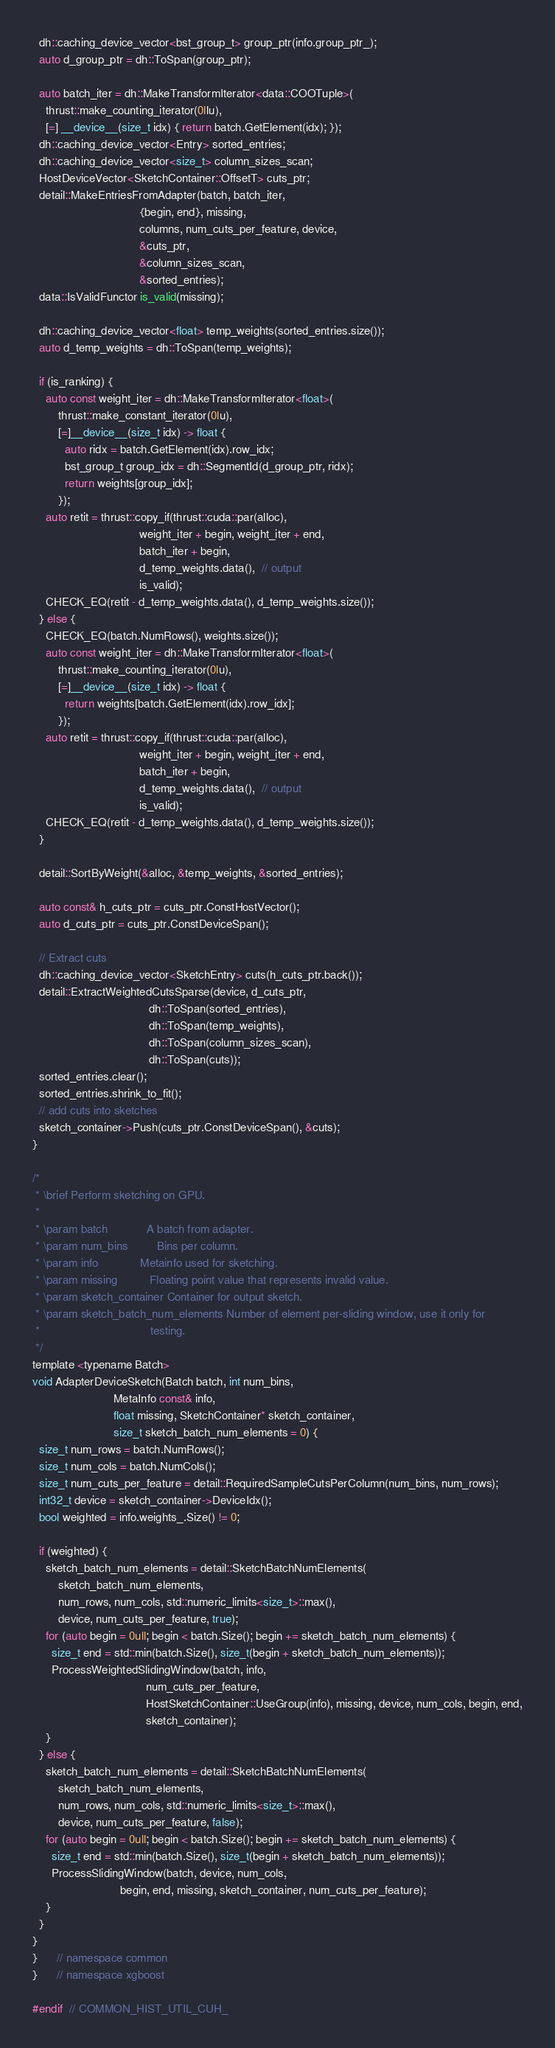Convert code to text. <code><loc_0><loc_0><loc_500><loc_500><_Cuda_>  dh::caching_device_vector<bst_group_t> group_ptr(info.group_ptr_);
  auto d_group_ptr = dh::ToSpan(group_ptr);

  auto batch_iter = dh::MakeTransformIterator<data::COOTuple>(
    thrust::make_counting_iterator(0llu),
    [=] __device__(size_t idx) { return batch.GetElement(idx); });
  dh::caching_device_vector<Entry> sorted_entries;
  dh::caching_device_vector<size_t> column_sizes_scan;
  HostDeviceVector<SketchContainer::OffsetT> cuts_ptr;
  detail::MakeEntriesFromAdapter(batch, batch_iter,
                                 {begin, end}, missing,
                                 columns, num_cuts_per_feature, device,
                                 &cuts_ptr,
                                 &column_sizes_scan,
                                 &sorted_entries);
  data::IsValidFunctor is_valid(missing);

  dh::caching_device_vector<float> temp_weights(sorted_entries.size());
  auto d_temp_weights = dh::ToSpan(temp_weights);

  if (is_ranking) {
    auto const weight_iter = dh::MakeTransformIterator<float>(
        thrust::make_constant_iterator(0lu),
        [=]__device__(size_t idx) -> float {
          auto ridx = batch.GetElement(idx).row_idx;
          bst_group_t group_idx = dh::SegmentId(d_group_ptr, ridx);
          return weights[group_idx];
        });
    auto retit = thrust::copy_if(thrust::cuda::par(alloc),
                                 weight_iter + begin, weight_iter + end,
                                 batch_iter + begin,
                                 d_temp_weights.data(),  // output
                                 is_valid);
    CHECK_EQ(retit - d_temp_weights.data(), d_temp_weights.size());
  } else {
    CHECK_EQ(batch.NumRows(), weights.size());
    auto const weight_iter = dh::MakeTransformIterator<float>(
        thrust::make_counting_iterator(0lu),
        [=]__device__(size_t idx) -> float {
          return weights[batch.GetElement(idx).row_idx];
        });
    auto retit = thrust::copy_if(thrust::cuda::par(alloc),
                                 weight_iter + begin, weight_iter + end,
                                 batch_iter + begin,
                                 d_temp_weights.data(),  // output
                                 is_valid);
    CHECK_EQ(retit - d_temp_weights.data(), d_temp_weights.size());
  }

  detail::SortByWeight(&alloc, &temp_weights, &sorted_entries);

  auto const& h_cuts_ptr = cuts_ptr.ConstHostVector();
  auto d_cuts_ptr = cuts_ptr.ConstDeviceSpan();

  // Extract cuts
  dh::caching_device_vector<SketchEntry> cuts(h_cuts_ptr.back());
  detail::ExtractWeightedCutsSparse(device, d_cuts_ptr,
                                    dh::ToSpan(sorted_entries),
                                    dh::ToSpan(temp_weights),
                                    dh::ToSpan(column_sizes_scan),
                                    dh::ToSpan(cuts));
  sorted_entries.clear();
  sorted_entries.shrink_to_fit();
  // add cuts into sketches
  sketch_container->Push(cuts_ptr.ConstDeviceSpan(), &cuts);
}

/*
 * \brief Perform sketching on GPU.
 *
 * \param batch            A batch from adapter.
 * \param num_bins         Bins per column.
 * \param info             Metainfo used for sketching.
 * \param missing          Floating point value that represents invalid value.
 * \param sketch_container Container for output sketch.
 * \param sketch_batch_num_elements Number of element per-sliding window, use it only for
 *                                  testing.
 */
template <typename Batch>
void AdapterDeviceSketch(Batch batch, int num_bins,
                         MetaInfo const& info,
                         float missing, SketchContainer* sketch_container,
                         size_t sketch_batch_num_elements = 0) {
  size_t num_rows = batch.NumRows();
  size_t num_cols = batch.NumCols();
  size_t num_cuts_per_feature = detail::RequiredSampleCutsPerColumn(num_bins, num_rows);
  int32_t device = sketch_container->DeviceIdx();
  bool weighted = info.weights_.Size() != 0;

  if (weighted) {
    sketch_batch_num_elements = detail::SketchBatchNumElements(
        sketch_batch_num_elements,
        num_rows, num_cols, std::numeric_limits<size_t>::max(),
        device, num_cuts_per_feature, true);
    for (auto begin = 0ull; begin < batch.Size(); begin += sketch_batch_num_elements) {
      size_t end = std::min(batch.Size(), size_t(begin + sketch_batch_num_elements));
      ProcessWeightedSlidingWindow(batch, info,
                                   num_cuts_per_feature,
                                   HostSketchContainer::UseGroup(info), missing, device, num_cols, begin, end,
                                   sketch_container);
    }
  } else {
    sketch_batch_num_elements = detail::SketchBatchNumElements(
        sketch_batch_num_elements,
        num_rows, num_cols, std::numeric_limits<size_t>::max(),
        device, num_cuts_per_feature, false);
    for (auto begin = 0ull; begin < batch.Size(); begin += sketch_batch_num_elements) {
      size_t end = std::min(batch.Size(), size_t(begin + sketch_batch_num_elements));
      ProcessSlidingWindow(batch, device, num_cols,
                           begin, end, missing, sketch_container, num_cuts_per_feature);
    }
  }
}
}      // namespace common
}      // namespace xgboost

#endif  // COMMON_HIST_UTIL_CUH_</code> 